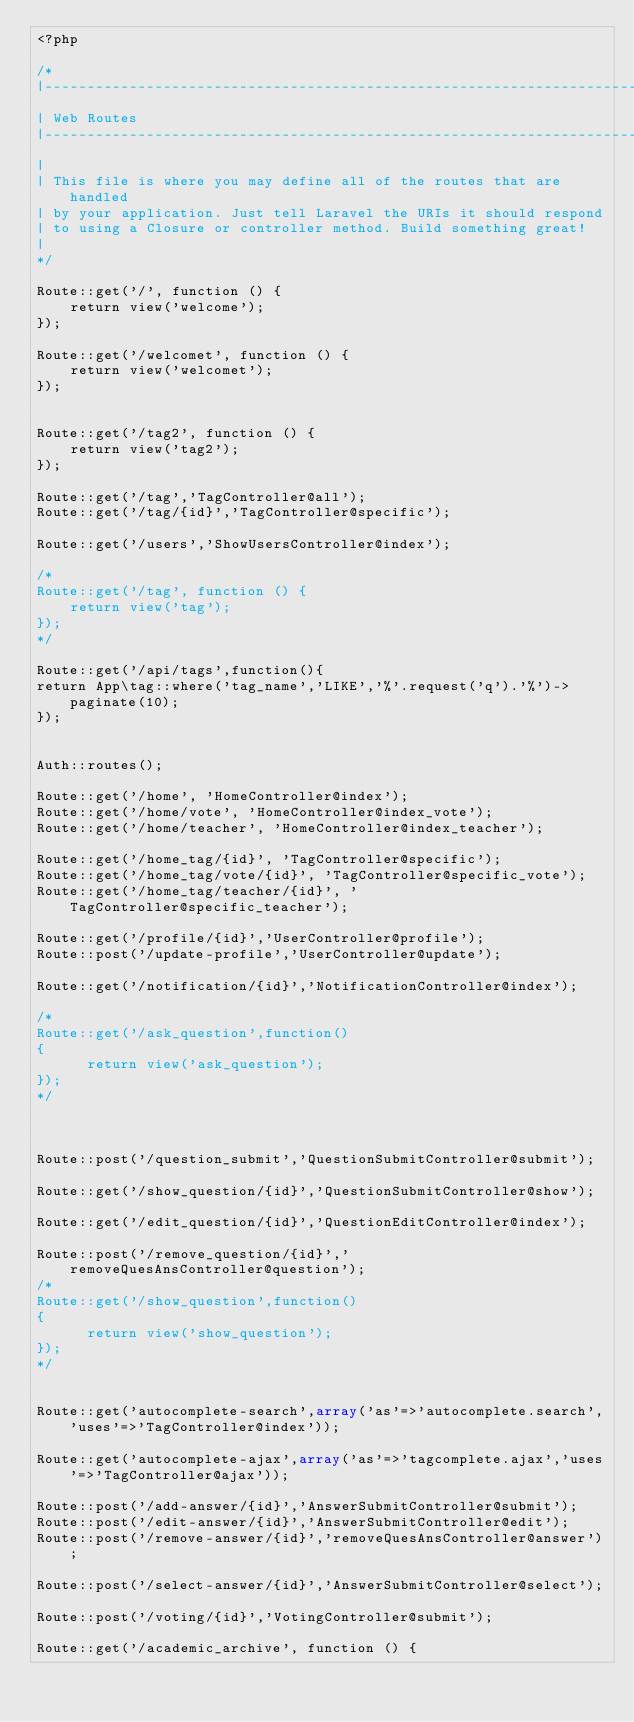<code> <loc_0><loc_0><loc_500><loc_500><_PHP_><?php

/*
|--------------------------------------------------------------------------
| Web Routes
|--------------------------------------------------------------------------
|
| This file is where you may define all of the routes that are handled
| by your application. Just tell Laravel the URIs it should respond
| to using a Closure or controller method. Build something great!
|
*/

Route::get('/', function () {
    return view('welcome');
});
  
Route::get('/welcomet', function () {
    return view('welcomet');
});


Route::get('/tag2', function () {
    return view('tag2');
});

Route::get('/tag','TagController@all');
Route::get('/tag/{id}','TagController@specific');
 
Route::get('/users','ShowUsersController@index');

/*
Route::get('/tag', function () {
    return view('tag');
});
*/
  
Route::get('/api/tags',function(){
return App\tag::where('tag_name','LIKE','%'.request('q').'%')->paginate(10);
});
 
 
Auth::routes(); 

Route::get('/home', 'HomeController@index'); 
Route::get('/home/vote', 'HomeController@index_vote'); 
Route::get('/home/teacher', 'HomeController@index_teacher');

Route::get('/home_tag/{id}', 'TagController@specific');
Route::get('/home_tag/vote/{id}', 'TagController@specific_vote'); 
Route::get('/home_tag/teacher/{id}', 'TagController@specific_teacher'); 
 
Route::get('/profile/{id}','UserController@profile'); 
Route::post('/update-profile','UserController@update');

Route::get('/notification/{id}','NotificationController@index');

/*
Route::get('/ask_question',function()
{
      return view('ask_question'); 
});
*/



Route::post('/question_submit','QuestionSubmitController@submit');

Route::get('/show_question/{id}','QuestionSubmitController@show');

Route::get('/edit_question/{id}','QuestionEditController@index');

Route::post('/remove_question/{id}','removeQuesAnsController@question');
/*
Route::get('/show_question',function()
{
      return view('show_question'); 
});
*/
   

Route::get('autocomplete-search',array('as'=>'autocomplete.search','uses'=>'TagController@index'));

Route::get('autocomplete-ajax',array('as'=>'tagcomplete.ajax','uses'=>'TagController@ajax'));

Route::post('/add-answer/{id}','AnswerSubmitController@submit');
Route::post('/edit-answer/{id}','AnswerSubmitController@edit');
Route::post('/remove-answer/{id}','removeQuesAnsController@answer');

Route::post('/select-answer/{id}','AnswerSubmitController@select');

Route::post('/voting/{id}','VotingController@submit');

Route::get('/academic_archive', function () {</code> 